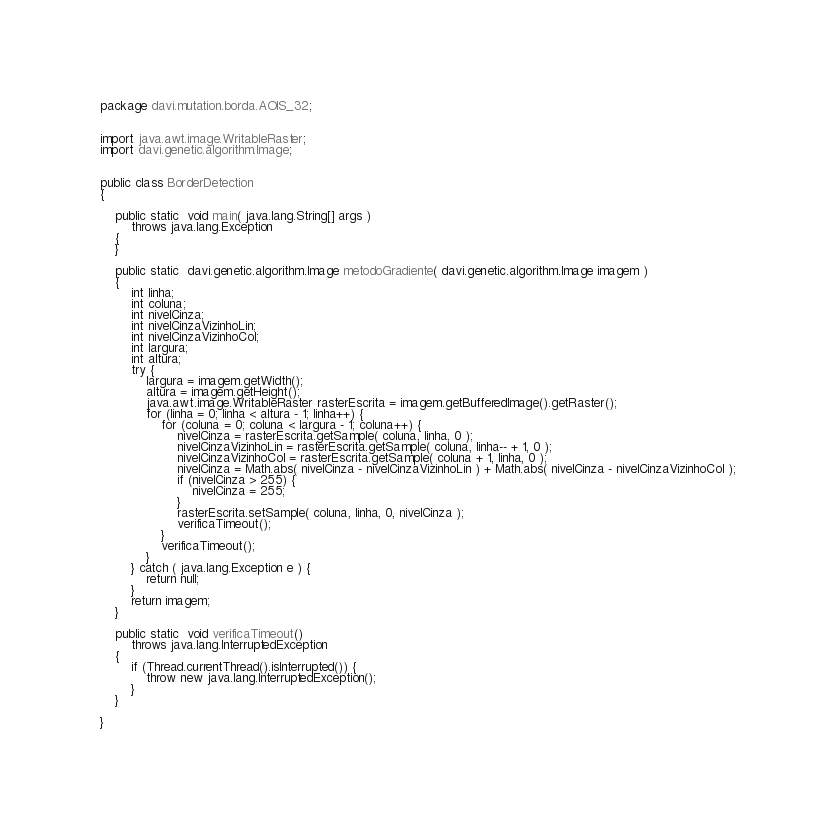<code> <loc_0><loc_0><loc_500><loc_500><_Java_>package davi.mutation.borda.AOIS_32;


import java.awt.image.WritableRaster;
import davi.genetic.algorithm.Image;


public class BorderDetection
{

    public static  void main( java.lang.String[] args )
        throws java.lang.Exception
    {
    }

    public static  davi.genetic.algorithm.Image metodoGradiente( davi.genetic.algorithm.Image imagem )
    {
        int linha;
        int coluna;
        int nivelCinza;
        int nivelCinzaVizinhoLin;
        int nivelCinzaVizinhoCol;
        int largura;
        int altura;
        try {
            largura = imagem.getWidth();
            altura = imagem.getHeight();
            java.awt.image.WritableRaster rasterEscrita = imagem.getBufferedImage().getRaster();
            for (linha = 0; linha < altura - 1; linha++) {
                for (coluna = 0; coluna < largura - 1; coluna++) {
                    nivelCinza = rasterEscrita.getSample( coluna, linha, 0 );
                    nivelCinzaVizinhoLin = rasterEscrita.getSample( coluna, linha-- + 1, 0 );
                    nivelCinzaVizinhoCol = rasterEscrita.getSample( coluna + 1, linha, 0 );
                    nivelCinza = Math.abs( nivelCinza - nivelCinzaVizinhoLin ) + Math.abs( nivelCinza - nivelCinzaVizinhoCol );
                    if (nivelCinza > 255) {
                        nivelCinza = 255;
                    }
                    rasterEscrita.setSample( coluna, linha, 0, nivelCinza );
                    verificaTimeout();
                }
                verificaTimeout();
            }
        } catch ( java.lang.Exception e ) {
            return null;
        }
        return imagem;
    }

    public static  void verificaTimeout()
        throws java.lang.InterruptedException
    {
        if (Thread.currentThread().isInterrupted()) {
            throw new java.lang.InterruptedException();
        }
    }

}
</code> 